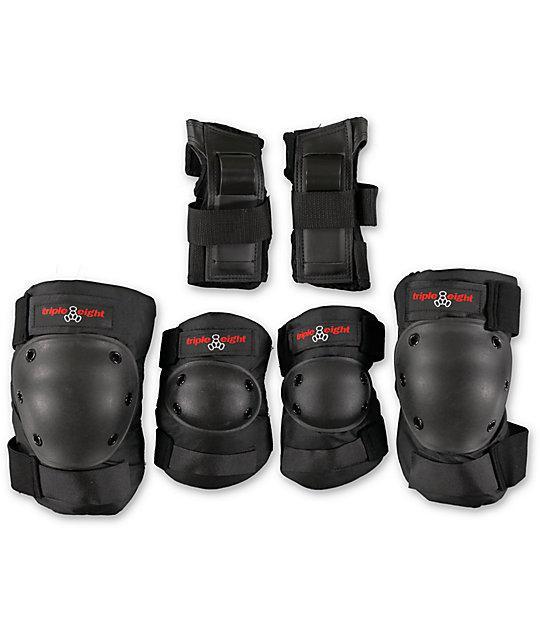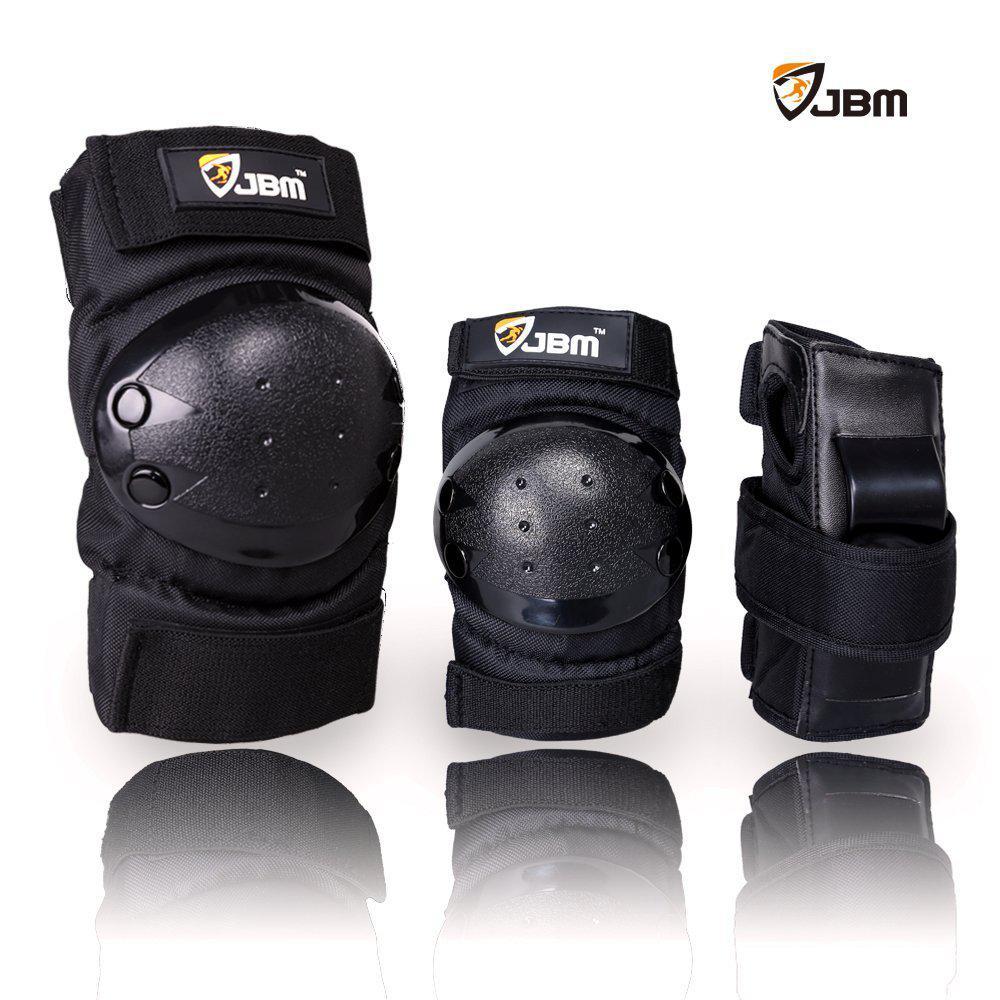The first image is the image on the left, the second image is the image on the right. Given the left and right images, does the statement "There are at least two sets of pads in the left image." hold true? Answer yes or no. Yes. The first image is the image on the left, the second image is the image on the right. Examine the images to the left and right. Is the description "One image shows more than three individual items of protective gear." accurate? Answer yes or no. Yes. 